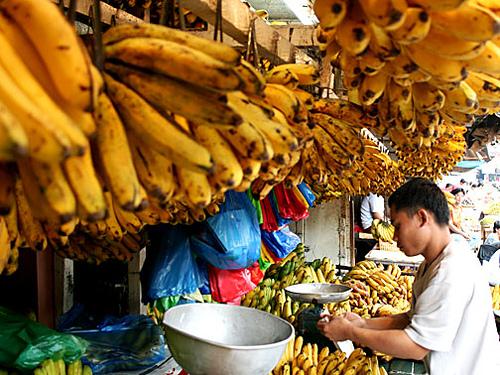Are there shopping bags available?
Concise answer only. Yes. What color is the mans t-shirt?
Be succinct. White. Are the bananas for sale?
Answer briefly. Yes. 